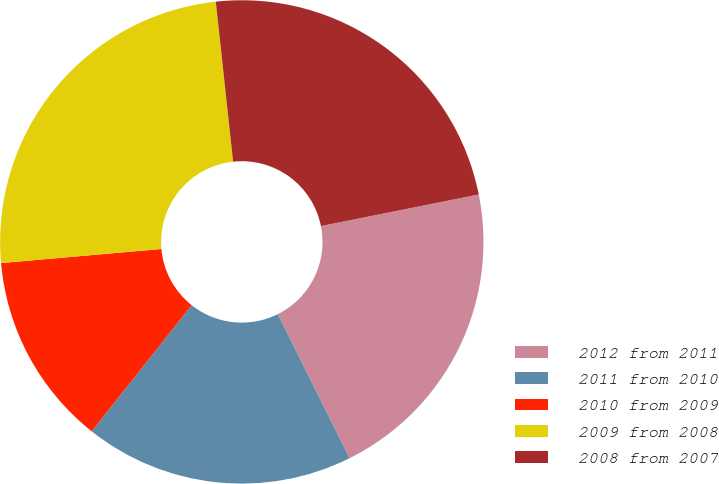<chart> <loc_0><loc_0><loc_500><loc_500><pie_chart><fcel>2012 from 2011<fcel>2011 from 2010<fcel>2010 from 2009<fcel>2009 from 2008<fcel>2008 from 2007<nl><fcel>20.79%<fcel>18.02%<fcel>12.94%<fcel>24.68%<fcel>23.57%<nl></chart> 